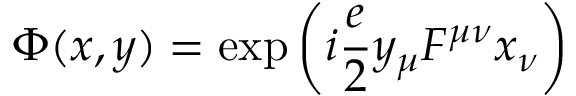<formula> <loc_0><loc_0><loc_500><loc_500>\Phi ( x , y ) = \exp \left ( i \frac { e } { 2 } y _ { \mu } F ^ { \mu \nu } x _ { \nu } \right )</formula> 